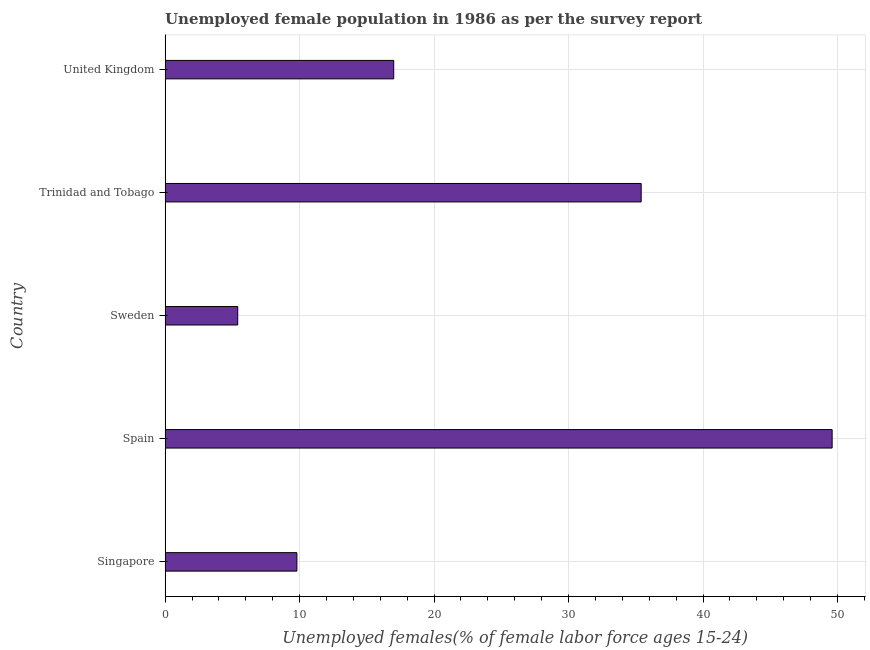Does the graph contain any zero values?
Offer a very short reply. No. What is the title of the graph?
Offer a very short reply. Unemployed female population in 1986 as per the survey report. What is the label or title of the X-axis?
Provide a short and direct response. Unemployed females(% of female labor force ages 15-24). What is the label or title of the Y-axis?
Your answer should be compact. Country. What is the unemployed female youth in Sweden?
Provide a short and direct response. 5.4. Across all countries, what is the maximum unemployed female youth?
Make the answer very short. 49.6. Across all countries, what is the minimum unemployed female youth?
Keep it short and to the point. 5.4. What is the sum of the unemployed female youth?
Your answer should be very brief. 117.2. What is the difference between the unemployed female youth in Singapore and Trinidad and Tobago?
Offer a terse response. -25.6. What is the average unemployed female youth per country?
Keep it short and to the point. 23.44. What is the median unemployed female youth?
Keep it short and to the point. 17. In how many countries, is the unemployed female youth greater than 48 %?
Your answer should be compact. 1. What is the ratio of the unemployed female youth in Singapore to that in Trinidad and Tobago?
Your answer should be very brief. 0.28. What is the difference between the highest and the second highest unemployed female youth?
Offer a very short reply. 14.2. What is the difference between the highest and the lowest unemployed female youth?
Your response must be concise. 44.2. What is the difference between two consecutive major ticks on the X-axis?
Provide a short and direct response. 10. Are the values on the major ticks of X-axis written in scientific E-notation?
Your answer should be compact. No. What is the Unemployed females(% of female labor force ages 15-24) of Singapore?
Provide a short and direct response. 9.8. What is the Unemployed females(% of female labor force ages 15-24) in Spain?
Your response must be concise. 49.6. What is the Unemployed females(% of female labor force ages 15-24) of Sweden?
Offer a terse response. 5.4. What is the Unemployed females(% of female labor force ages 15-24) of Trinidad and Tobago?
Your answer should be very brief. 35.4. What is the difference between the Unemployed females(% of female labor force ages 15-24) in Singapore and Spain?
Ensure brevity in your answer.  -39.8. What is the difference between the Unemployed females(% of female labor force ages 15-24) in Singapore and Sweden?
Your answer should be compact. 4.4. What is the difference between the Unemployed females(% of female labor force ages 15-24) in Singapore and Trinidad and Tobago?
Keep it short and to the point. -25.6. What is the difference between the Unemployed females(% of female labor force ages 15-24) in Singapore and United Kingdom?
Make the answer very short. -7.2. What is the difference between the Unemployed females(% of female labor force ages 15-24) in Spain and Sweden?
Provide a succinct answer. 44.2. What is the difference between the Unemployed females(% of female labor force ages 15-24) in Spain and United Kingdom?
Your answer should be very brief. 32.6. What is the difference between the Unemployed females(% of female labor force ages 15-24) in Sweden and Trinidad and Tobago?
Provide a succinct answer. -30. What is the difference between the Unemployed females(% of female labor force ages 15-24) in Trinidad and Tobago and United Kingdom?
Provide a succinct answer. 18.4. What is the ratio of the Unemployed females(% of female labor force ages 15-24) in Singapore to that in Spain?
Your response must be concise. 0.2. What is the ratio of the Unemployed females(% of female labor force ages 15-24) in Singapore to that in Sweden?
Make the answer very short. 1.81. What is the ratio of the Unemployed females(% of female labor force ages 15-24) in Singapore to that in Trinidad and Tobago?
Offer a terse response. 0.28. What is the ratio of the Unemployed females(% of female labor force ages 15-24) in Singapore to that in United Kingdom?
Give a very brief answer. 0.58. What is the ratio of the Unemployed females(% of female labor force ages 15-24) in Spain to that in Sweden?
Your response must be concise. 9.19. What is the ratio of the Unemployed females(% of female labor force ages 15-24) in Spain to that in Trinidad and Tobago?
Offer a very short reply. 1.4. What is the ratio of the Unemployed females(% of female labor force ages 15-24) in Spain to that in United Kingdom?
Make the answer very short. 2.92. What is the ratio of the Unemployed females(% of female labor force ages 15-24) in Sweden to that in Trinidad and Tobago?
Offer a very short reply. 0.15. What is the ratio of the Unemployed females(% of female labor force ages 15-24) in Sweden to that in United Kingdom?
Provide a succinct answer. 0.32. What is the ratio of the Unemployed females(% of female labor force ages 15-24) in Trinidad and Tobago to that in United Kingdom?
Ensure brevity in your answer.  2.08. 